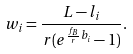<formula> <loc_0><loc_0><loc_500><loc_500>w _ { i } = \frac { L - l _ { i } } { r ( e ^ { \frac { f _ { B } } { r } b _ { i } } - 1 ) } .</formula> 